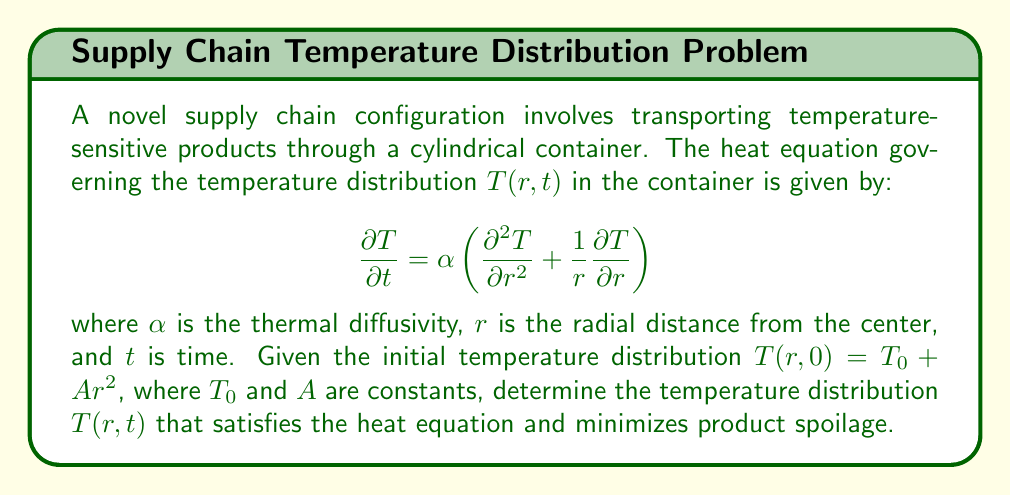Could you help me with this problem? To solve this problem, we'll follow these steps:

1) The given heat equation is in cylindrical coordinates, and we need to find a solution that satisfies both the equation and the initial condition.

2) Let's assume a solution of the form:

   $$T(r,t) = T_0 + f(t)r^2$$

   where $f(t)$ is a function of time to be determined.

3) Substitute this into the heat equation:

   $$\frac{\partial T}{\partial t} = f'(t)r^2$$
   $$\frac{\partial T}{\partial r} = 2f(t)r$$
   $$\frac{\partial^2 T}{\partial r^2} = 2f(t)$$

4) Plugging these into the heat equation:

   $$f'(t)r^2 = \alpha \left(2f(t) + \frac{1}{r}2f(t)r\right) = 4\alpha f(t)$$

5) For this to be true for all $r$, we must have:

   $$f'(t) = 4\alpha f(t)$$

6) The solution to this differential equation is:

   $$f(t) = Ce^{4\alpha t}$$

   where $C$ is a constant.

7) Now, let's use the initial condition to determine $C$:

   $$T(r,0) = T_0 + Ar^2 = T_0 + f(0)r^2$$

   Therefore, $f(0) = A$, so $C = A$.

8) The complete solution is:

   $$T(r,t) = T_0 + Ae^{4\alpha t}r^2$$

9) To minimize product spoilage, we want to minimize temperature fluctuations. This occurs when $A$ is as small as possible, ideally zero.
Answer: $T(r,t) = T_0 + Ae^{4\alpha t}r^2$, with $A \approx 0$ to minimize spoilage. 